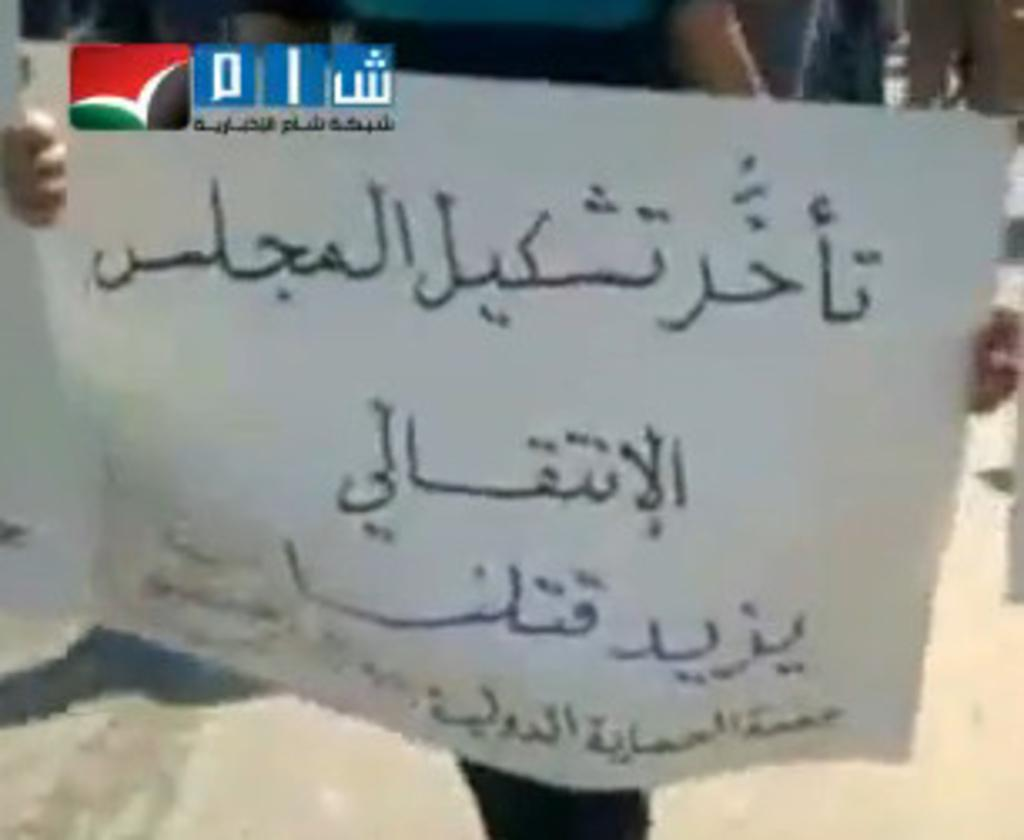What is the person in the image doing? The person in the image is holding a placard. How is the placard being held? The placard is held with the person's hands. Can you describe the logo in the top left of the image? Unfortunately, there is no information provided about the logo in the image. What type of stove can be seen in the image? There is no stove present in the image. How does the person make their decision in the image? The image does not show the person making a decision, so we cannot determine how they make their decision. 